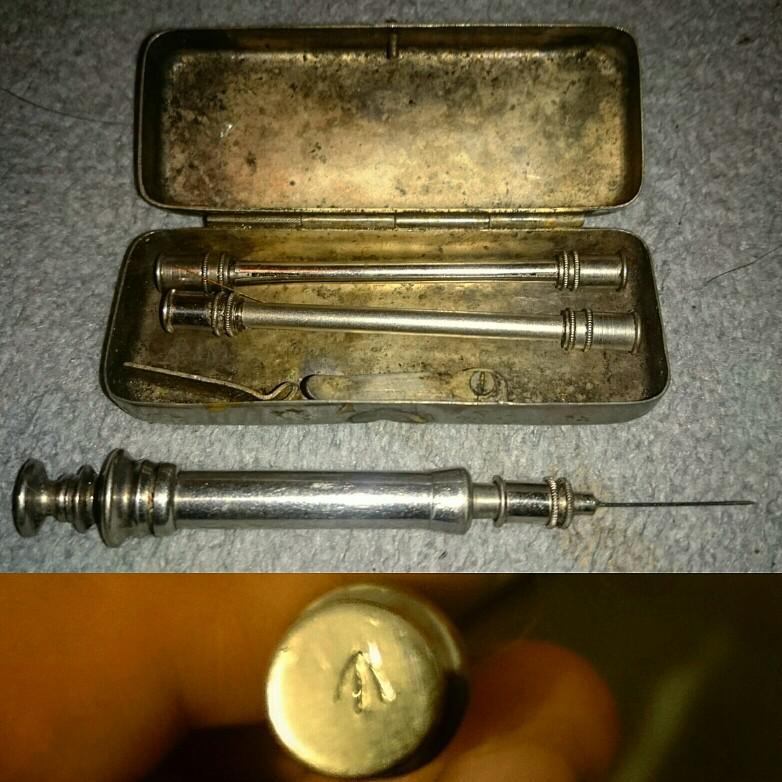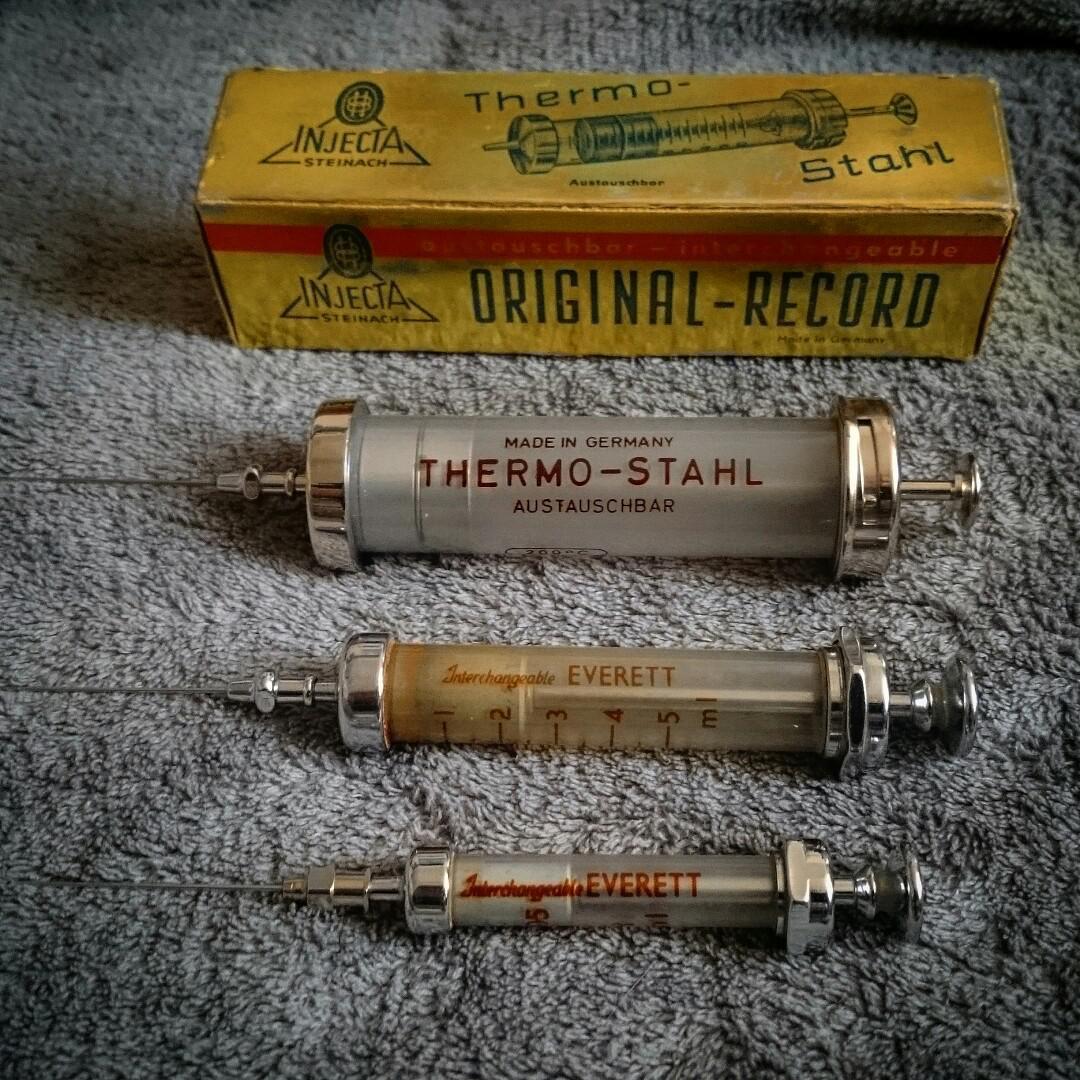The first image is the image on the left, the second image is the image on the right. Considering the images on both sides, is "An image shows one open rectangular metal case with syringe items inside of it." valid? Answer yes or no. Yes. 